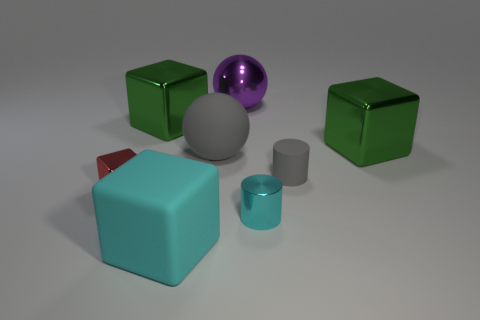There is a green metallic cube that is on the right side of the tiny gray cylinder; what size is it?
Give a very brief answer. Large. What number of cyan metal objects have the same size as the shiny ball?
Offer a terse response. 0. What material is the block that is left of the cyan rubber object and behind the red thing?
Make the answer very short. Metal. There is a cyan thing that is the same size as the rubber sphere; what material is it?
Provide a short and direct response. Rubber. What size is the green shiny object that is left of the small thing behind the small metal object left of the large cyan rubber block?
Your answer should be compact. Large. What is the size of the cyan cube that is the same material as the tiny gray cylinder?
Your answer should be very brief. Large. Is the size of the red cube the same as the shiny thing that is in front of the small red cube?
Make the answer very short. Yes. There is a rubber thing that is to the right of the shiny sphere; what shape is it?
Your answer should be very brief. Cylinder. There is a large metallic cube that is left of the tiny cylinder that is in front of the tiny red metal object; are there any tiny gray matte things in front of it?
Offer a terse response. Yes. What material is the other cyan object that is the same shape as the small rubber thing?
Your answer should be very brief. Metal. 